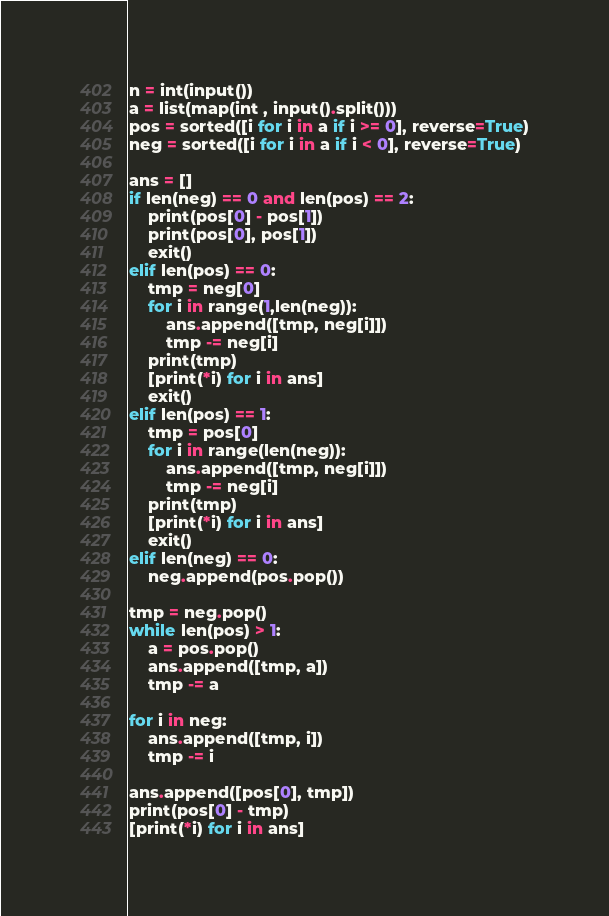Convert code to text. <code><loc_0><loc_0><loc_500><loc_500><_Python_>n = int(input())
a = list(map(int , input().split()))
pos = sorted([i for i in a if i >= 0], reverse=True)
neg = sorted([i for i in a if i < 0], reverse=True)

ans = []
if len(neg) == 0 and len(pos) == 2:
    print(pos[0] - pos[1])
    print(pos[0], pos[1])
    exit()
elif len(pos) == 0:
    tmp = neg[0]
    for i in range(1,len(neg)):
        ans.append([tmp, neg[i]])
        tmp -= neg[i]
    print(tmp)
    [print(*i) for i in ans]
    exit()
elif len(pos) == 1:
    tmp = pos[0]
    for i in range(len(neg)):
        ans.append([tmp, neg[i]])
        tmp -= neg[i]
    print(tmp)
    [print(*i) for i in ans]
    exit()
elif len(neg) == 0:
    neg.append(pos.pop())

tmp = neg.pop()
while len(pos) > 1:
    a = pos.pop()
    ans.append([tmp, a])
    tmp -= a

for i in neg:
    ans.append([tmp, i])
    tmp -= i

ans.append([pos[0], tmp])
print(pos[0] - tmp)
[print(*i) for i in ans]
</code> 